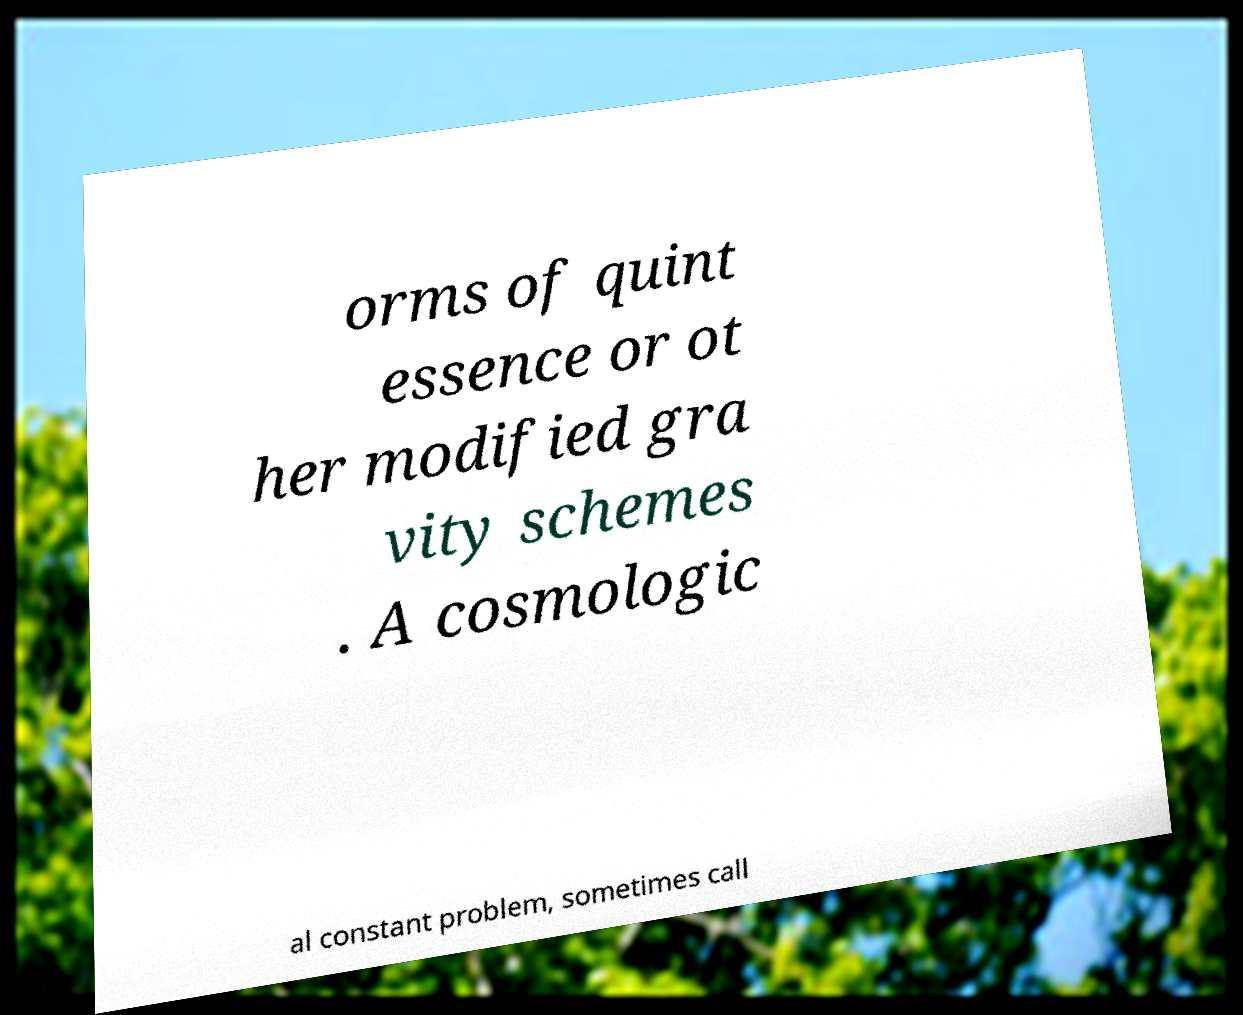I need the written content from this picture converted into text. Can you do that? orms of quint essence or ot her modified gra vity schemes . A cosmologic al constant problem, sometimes call 